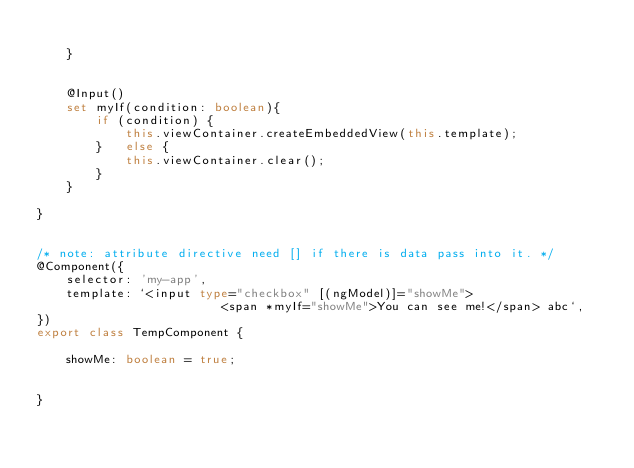Convert code to text. <code><loc_0><loc_0><loc_500><loc_500><_TypeScript_>		
	}


	@Input()
	set myIf(condition: boolean){
		if (condition) {
			this.viewContainer.createEmbeddedView(this.template);
		}	else {
			this.viewContainer.clear();
		}
	}

}


/* note: attribute directive need [] if there is data pass into it. */
@Component({
	selector: 'my-app',
	template: `<input type="checkbox" [(ngModel)]="showMe">
						 <span *myIf="showMe">You can see me!</span> abc`,
})
export class TempComponent {

	showMe: boolean = true;
	
	
}

</code> 